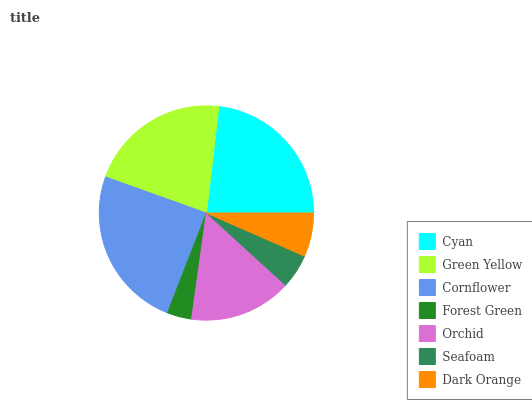Is Forest Green the minimum?
Answer yes or no. Yes. Is Cornflower the maximum?
Answer yes or no. Yes. Is Green Yellow the minimum?
Answer yes or no. No. Is Green Yellow the maximum?
Answer yes or no. No. Is Cyan greater than Green Yellow?
Answer yes or no. Yes. Is Green Yellow less than Cyan?
Answer yes or no. Yes. Is Green Yellow greater than Cyan?
Answer yes or no. No. Is Cyan less than Green Yellow?
Answer yes or no. No. Is Orchid the high median?
Answer yes or no. Yes. Is Orchid the low median?
Answer yes or no. Yes. Is Dark Orange the high median?
Answer yes or no. No. Is Dark Orange the low median?
Answer yes or no. No. 